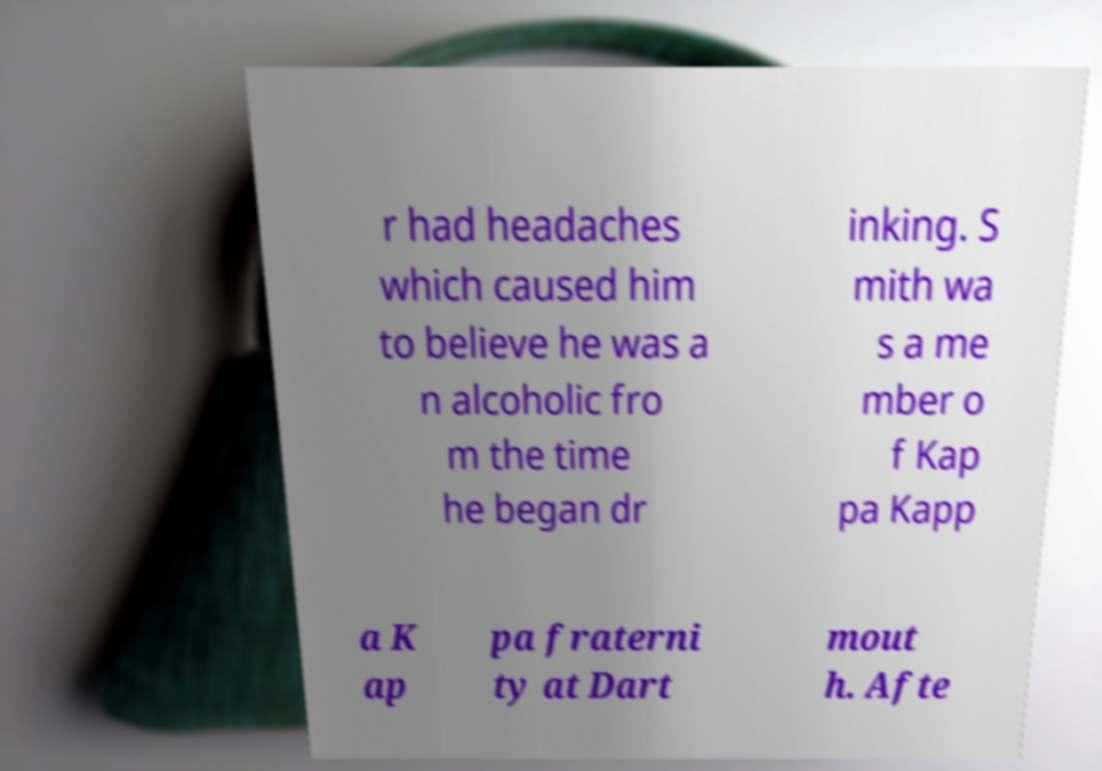Could you extract and type out the text from this image? r had headaches which caused him to believe he was a n alcoholic fro m the time he began dr inking. S mith wa s a me mber o f Kap pa Kapp a K ap pa fraterni ty at Dart mout h. Afte 